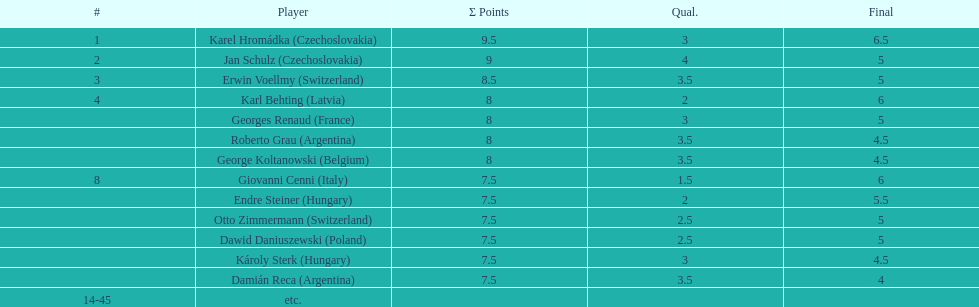How many participants tied for 4th position? 4. Parse the full table. {'header': ['#', 'Player', 'Σ Points', 'Qual.', 'Final'], 'rows': [['1', 'Karel Hromádka\xa0(Czechoslovakia)', '9.5', '3', '6.5'], ['2', 'Jan Schulz\xa0(Czechoslovakia)', '9', '4', '5'], ['3', 'Erwin Voellmy\xa0(Switzerland)', '8.5', '3.5', '5'], ['4', 'Karl Behting\xa0(Latvia)', '8', '2', '6'], ['', 'Georges Renaud\xa0(France)', '8', '3', '5'], ['', 'Roberto Grau\xa0(Argentina)', '8', '3.5', '4.5'], ['', 'George Koltanowski\xa0(Belgium)', '8', '3.5', '4.5'], ['8', 'Giovanni Cenni\xa0(Italy)', '7.5', '1.5', '6'], ['', 'Endre Steiner\xa0(Hungary)', '7.5', '2', '5.5'], ['', 'Otto Zimmermann\xa0(Switzerland)', '7.5', '2.5', '5'], ['', 'Dawid Daniuszewski\xa0(Poland)', '7.5', '2.5', '5'], ['', 'Károly Sterk\xa0(Hungary)', '7.5', '3', '4.5'], ['', 'Damián Reca\xa0(Argentina)', '7.5', '3.5', '4'], ['14-45', 'etc.', '', '', '']]} 